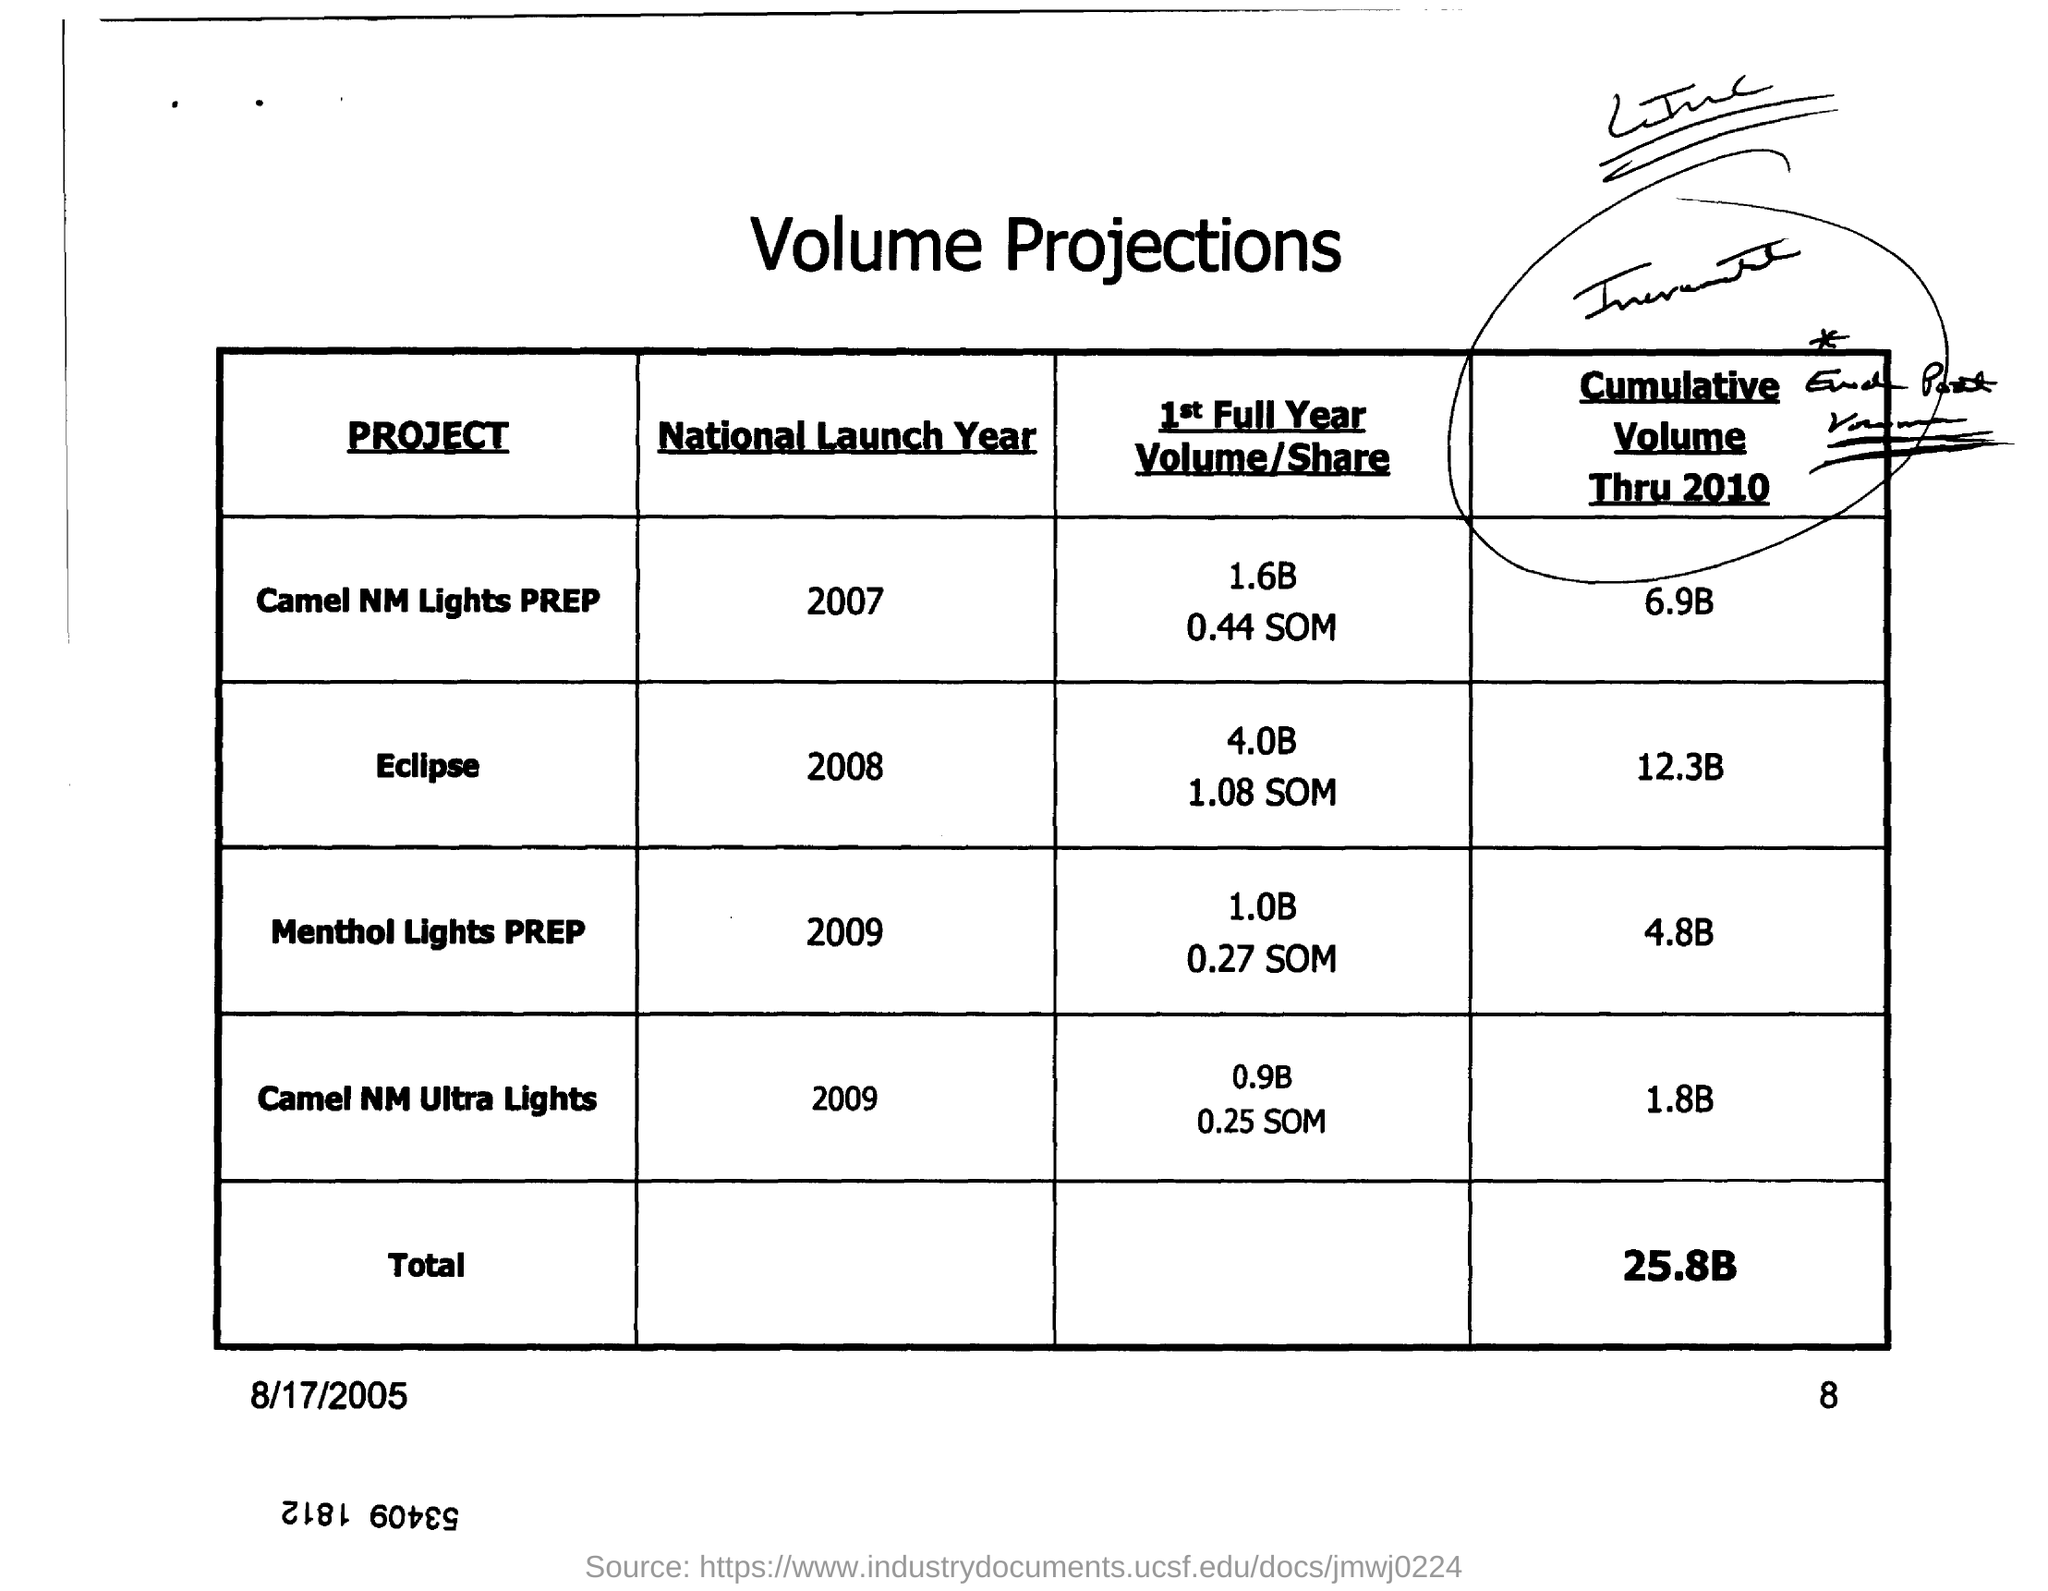What is the "National Launch Year" for "Eclipse"?
Make the answer very short. 2008. What is the "National Launch Year" for "Camel NM Ultra Lights"?
Ensure brevity in your answer.  2009. What is the "Cumulative Volume Thru 2010" for "Camel NM Ultra Lights"?
Keep it short and to the point. 1.8B. What is the "total" for "cumulative volume thru 2010"?
Make the answer very short. 25.8B. 